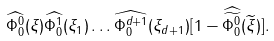<formula> <loc_0><loc_0><loc_500><loc_500>\widehat { \Phi ^ { 0 } _ { 0 } } ( \xi ) \widehat { \Phi ^ { 1 } _ { 0 } } ( \xi _ { 1 } ) \dots \widehat { \Phi ^ { d + 1 } _ { 0 } } ( \xi _ { d + 1 } ) [ 1 - \widehat { \widetilde { \Phi ^ { 0 } _ { 0 } } } ( \widetilde { \xi } ) ] .</formula> 